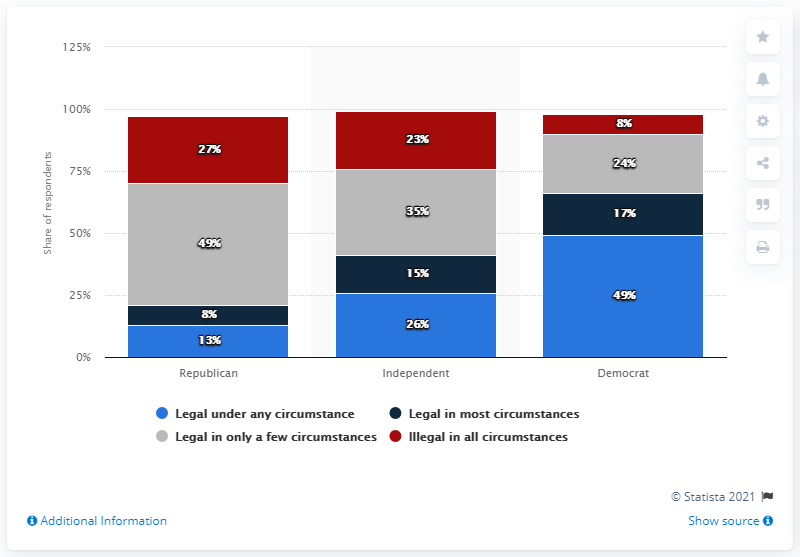What can we infer about the political landscape and its impact on opinions about abortion legalization? The data suggests that opinions on abortion legalization are highly correlated with political affiliation, with Democrats demonstrating the highest levels of support for legalization and Republicans showing the least. This reflects the broader political landscape where social issues often align with party ideologies, with Democrats typically advocating for more liberal stances on women's reproductive rights and Republicans often holding more conservative views. The chart underscores the deep partisan divide on this topic. 